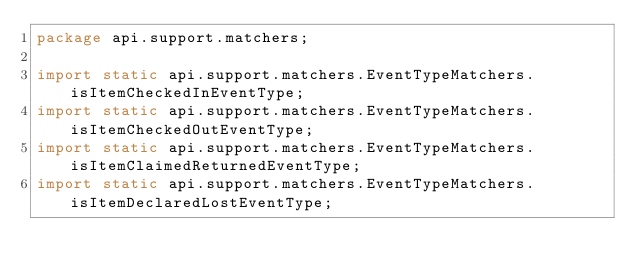<code> <loc_0><loc_0><loc_500><loc_500><_Java_>package api.support.matchers;

import static api.support.matchers.EventTypeMatchers.isItemCheckedInEventType;
import static api.support.matchers.EventTypeMatchers.isItemCheckedOutEventType;
import static api.support.matchers.EventTypeMatchers.isItemClaimedReturnedEventType;
import static api.support.matchers.EventTypeMatchers.isItemDeclaredLostEventType;</code> 